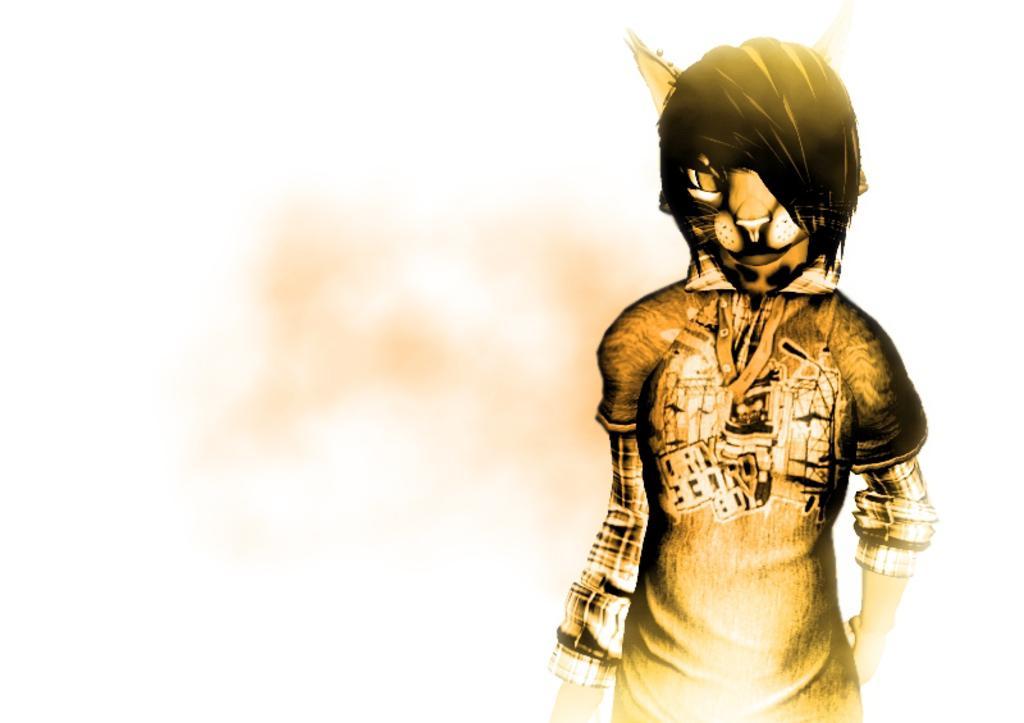Describe this image in one or two sentences. In the image there is an animated picture in the foreground. 